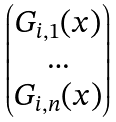<formula> <loc_0><loc_0><loc_500><loc_500>\begin{pmatrix} G _ { i , 1 } ( x ) \\ \dots \\ G _ { i , n } ( x ) \end{pmatrix}</formula> 